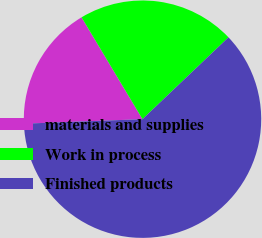<chart> <loc_0><loc_0><loc_500><loc_500><pie_chart><fcel>materials and supplies<fcel>Work in process<fcel>Finished products<nl><fcel>17.02%<fcel>21.47%<fcel>61.5%<nl></chart> 